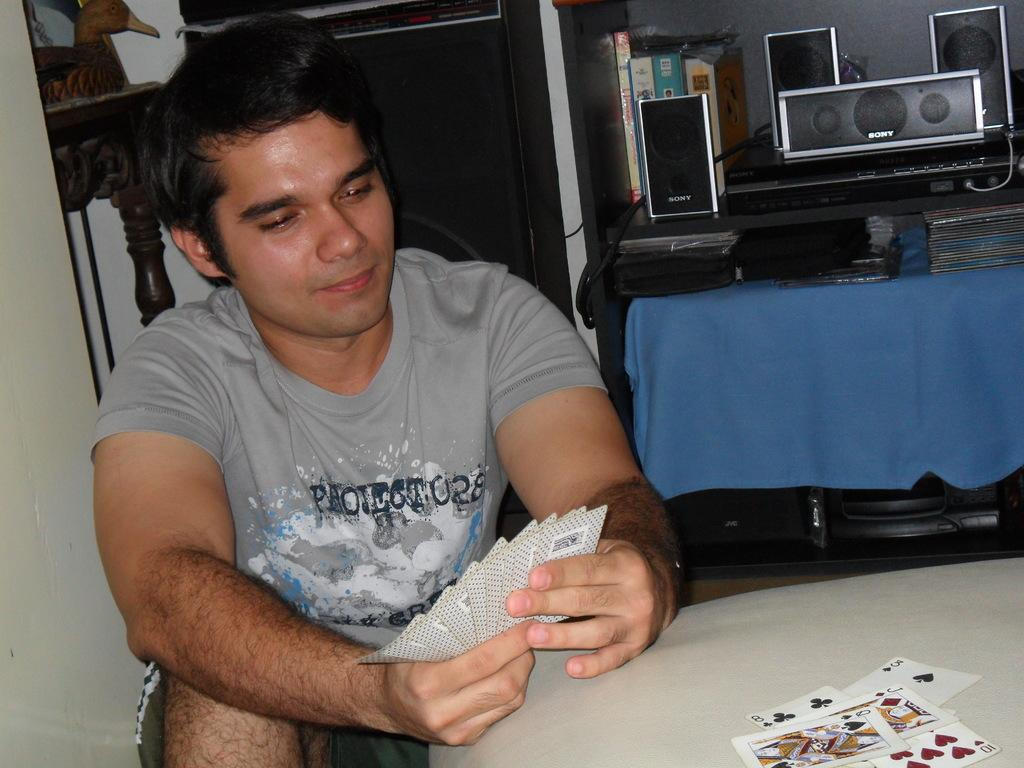What is the person in the image doing? The person is holding cards in the image. What is the person holding the cards standing near? The person is standing near a table in the image. What can be seen on the table? There are speakers and boxes on the table in the image. What is the color or texture of the cloth in the image? The cloth in the image is not described in terms of color or texture. What is the purpose of the other objects in the image? The purpose of the other objects in the image is not specified. What is on the left side of the image? There is a wall on the left side of the image. What type of pail is being used for teaching in the image? There is no pail present in the image, and no teaching activity is depicted. 